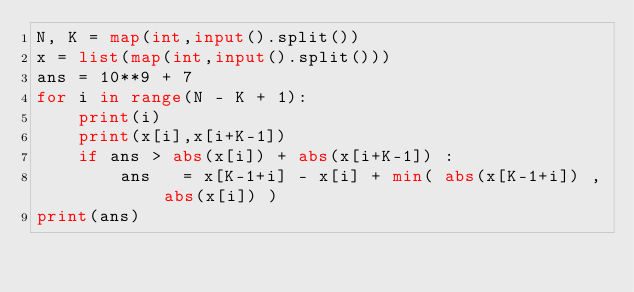<code> <loc_0><loc_0><loc_500><loc_500><_Python_>N, K = map(int,input().split())
x = list(map(int,input().split()))
ans = 10**9 + 7
for i in range(N - K + 1):
	print(i)
	print(x[i],x[i+K-1])
	if ans > abs(x[i]) + abs(x[i+K-1]) :
		ans   = x[K-1+i] - x[i] + min( abs(x[K-1+i]) , abs(x[i]) )
print(ans)
</code> 